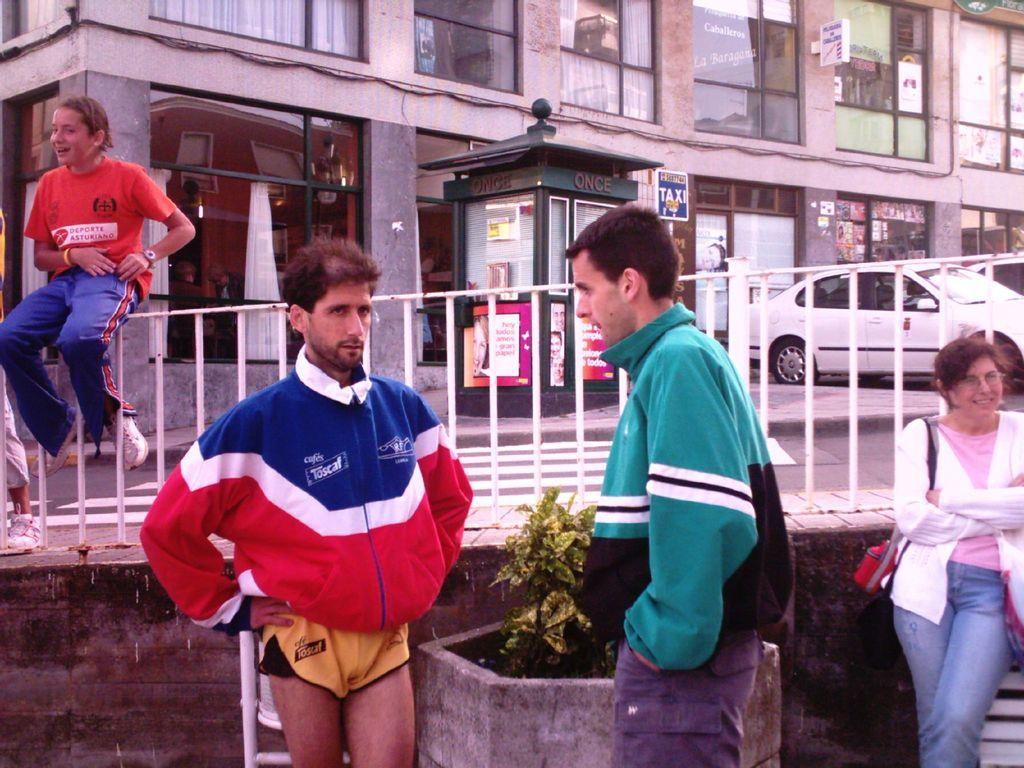<image>
Relay a brief, clear account of the picture shown. A man in yellow shorts has the word Toscal on his jacket 